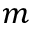<formula> <loc_0><loc_0><loc_500><loc_500>m</formula> 